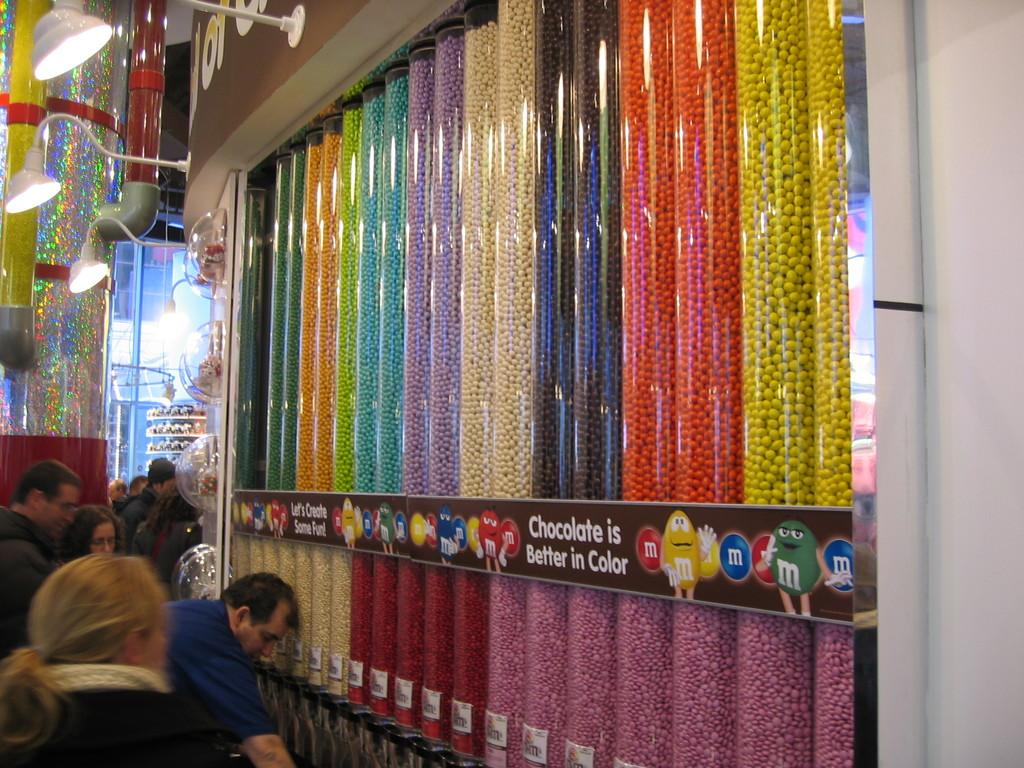<image>
Present a compact description of the photo's key features. Series of dispensers containing M&M's of different colors. 